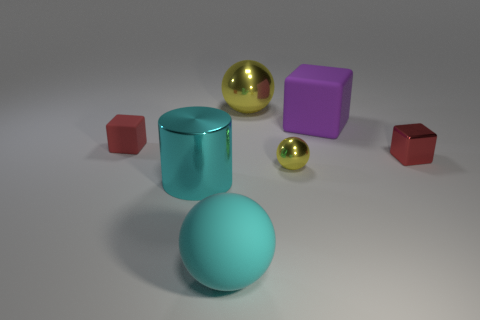Add 2 big gray metal cubes. How many objects exist? 9 Subtract all cubes. How many objects are left? 4 Add 6 small yellow shiny spheres. How many small yellow shiny spheres exist? 7 Subtract 0 gray balls. How many objects are left? 7 Subtract all metal cubes. Subtract all tiny yellow metal things. How many objects are left? 5 Add 5 small cubes. How many small cubes are left? 7 